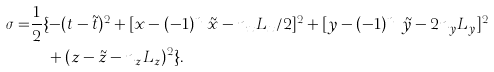<formula> <loc_0><loc_0><loc_500><loc_500>\sigma = & \frac { 1 } { 2 } \{ - ( t - \tilde { t } ) ^ { 2 } + [ x - ( - 1 ) ^ { n _ { z } } \tilde { x } - n _ { x } L _ { x } / 2 ] ^ { 2 } + [ y - ( - 1 ) ^ { n _ { x } } \tilde { y } - 2 n _ { y } L _ { y } ] ^ { 2 } \\ & \quad + ( z - \tilde { z } - n _ { z } L _ { z } ) ^ { 2 } \} .</formula> 